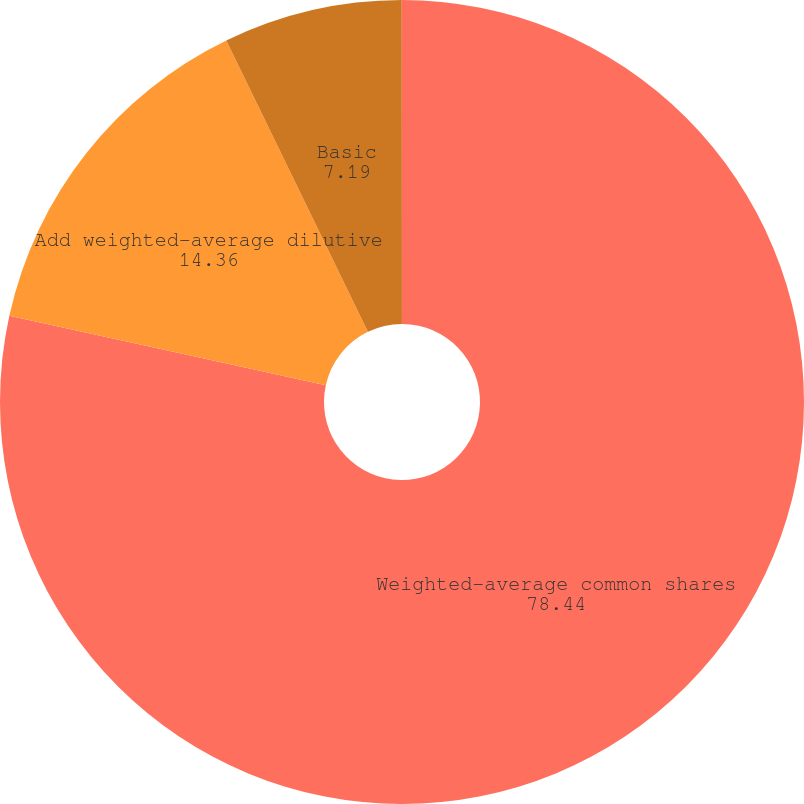Convert chart to OTSL. <chart><loc_0><loc_0><loc_500><loc_500><pie_chart><fcel>Weighted-average common shares<fcel>Add weighted-average dilutive<fcel>Basic<fcel>Diluted<nl><fcel>78.44%<fcel>14.36%<fcel>7.19%<fcel>0.01%<nl></chart> 